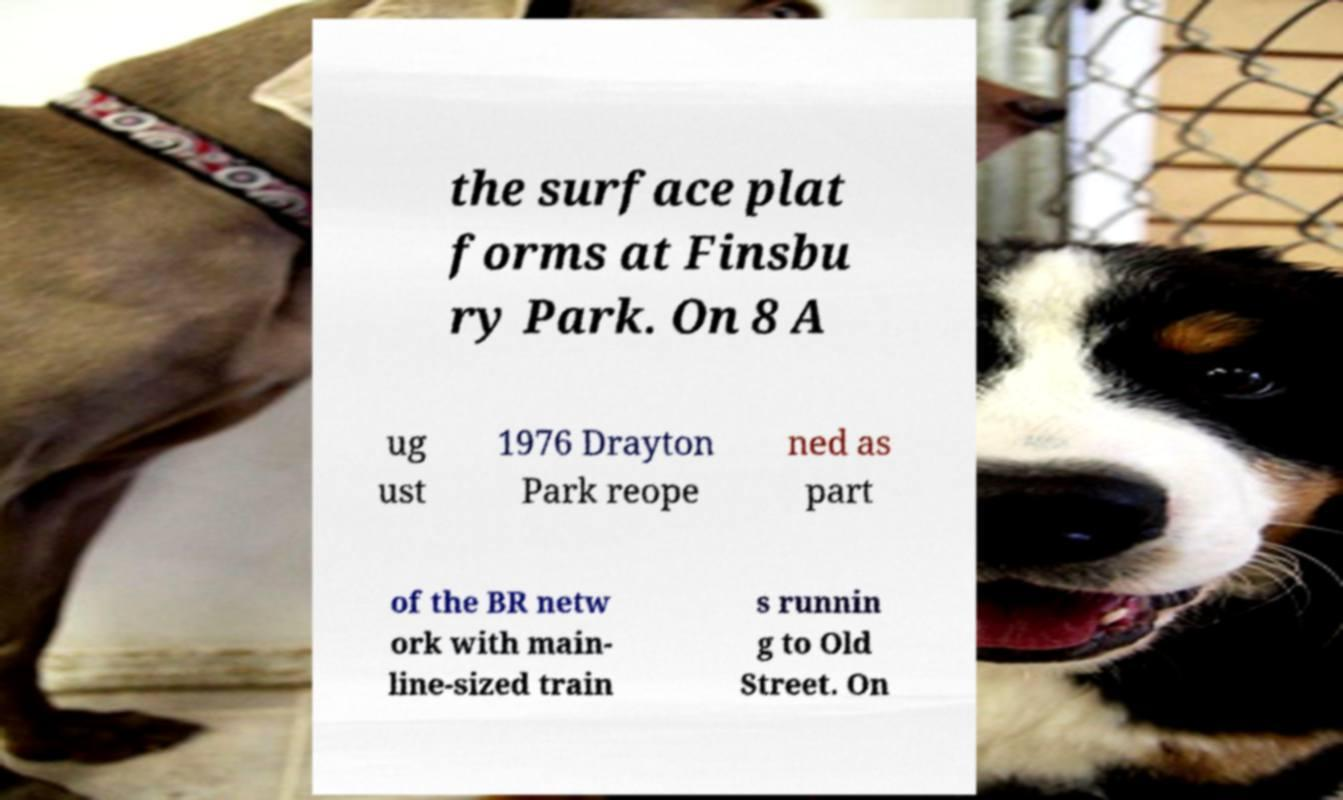Please read and relay the text visible in this image. What does it say? the surface plat forms at Finsbu ry Park. On 8 A ug ust 1976 Drayton Park reope ned as part of the BR netw ork with main- line-sized train s runnin g to Old Street. On 